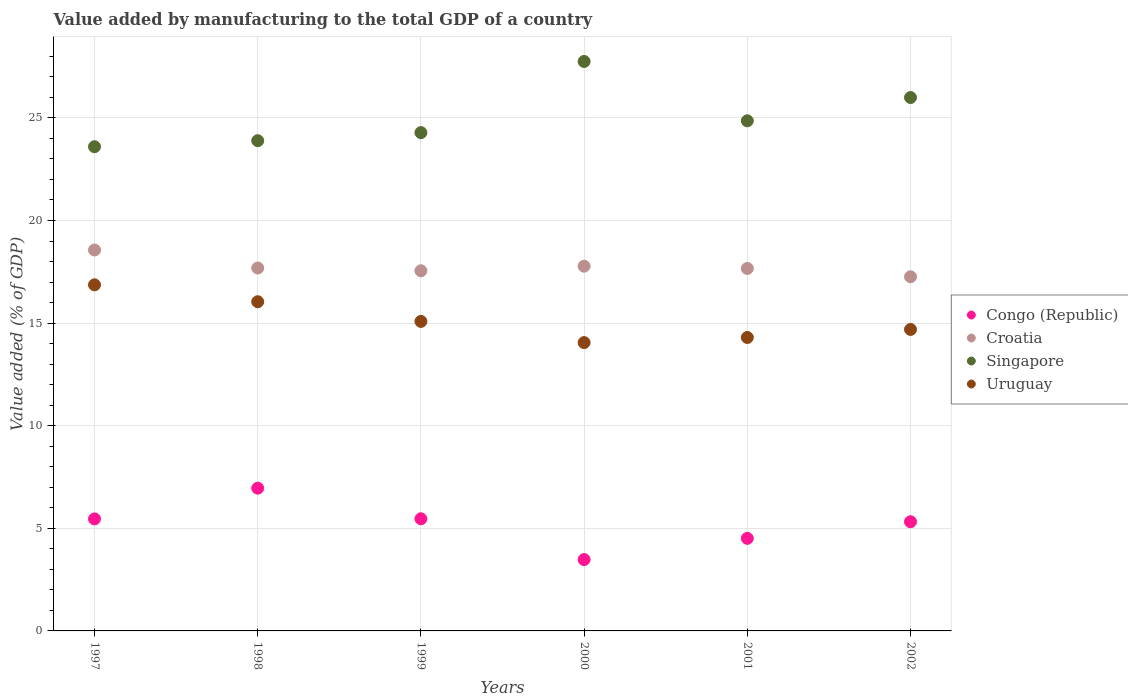How many different coloured dotlines are there?
Provide a succinct answer. 4. What is the value added by manufacturing to the total GDP in Uruguay in 2002?
Your answer should be very brief. 14.69. Across all years, what is the maximum value added by manufacturing to the total GDP in Singapore?
Keep it short and to the point. 27.75. Across all years, what is the minimum value added by manufacturing to the total GDP in Croatia?
Your answer should be very brief. 17.26. What is the total value added by manufacturing to the total GDP in Uruguay in the graph?
Offer a very short reply. 91.03. What is the difference between the value added by manufacturing to the total GDP in Croatia in 1999 and that in 2001?
Give a very brief answer. -0.11. What is the difference between the value added by manufacturing to the total GDP in Congo (Republic) in 2002 and the value added by manufacturing to the total GDP in Singapore in 1999?
Ensure brevity in your answer.  -18.96. What is the average value added by manufacturing to the total GDP in Congo (Republic) per year?
Make the answer very short. 5.2. In the year 1999, what is the difference between the value added by manufacturing to the total GDP in Uruguay and value added by manufacturing to the total GDP in Croatia?
Ensure brevity in your answer.  -2.47. In how many years, is the value added by manufacturing to the total GDP in Congo (Republic) greater than 1 %?
Ensure brevity in your answer.  6. What is the ratio of the value added by manufacturing to the total GDP in Singapore in 1998 to that in 2000?
Give a very brief answer. 0.86. What is the difference between the highest and the second highest value added by manufacturing to the total GDP in Croatia?
Provide a short and direct response. 0.79. What is the difference between the highest and the lowest value added by manufacturing to the total GDP in Congo (Republic)?
Keep it short and to the point. 3.48. In how many years, is the value added by manufacturing to the total GDP in Congo (Republic) greater than the average value added by manufacturing to the total GDP in Congo (Republic) taken over all years?
Offer a very short reply. 4. Is it the case that in every year, the sum of the value added by manufacturing to the total GDP in Congo (Republic) and value added by manufacturing to the total GDP in Croatia  is greater than the sum of value added by manufacturing to the total GDP in Uruguay and value added by manufacturing to the total GDP in Singapore?
Keep it short and to the point. No. Is it the case that in every year, the sum of the value added by manufacturing to the total GDP in Croatia and value added by manufacturing to the total GDP in Uruguay  is greater than the value added by manufacturing to the total GDP in Congo (Republic)?
Offer a terse response. Yes. How many dotlines are there?
Your answer should be compact. 4. Are the values on the major ticks of Y-axis written in scientific E-notation?
Offer a terse response. No. How many legend labels are there?
Provide a short and direct response. 4. What is the title of the graph?
Offer a terse response. Value added by manufacturing to the total GDP of a country. What is the label or title of the X-axis?
Your answer should be compact. Years. What is the label or title of the Y-axis?
Provide a short and direct response. Value added (% of GDP). What is the Value added (% of GDP) in Congo (Republic) in 1997?
Offer a very short reply. 5.46. What is the Value added (% of GDP) of Croatia in 1997?
Your answer should be compact. 18.56. What is the Value added (% of GDP) in Singapore in 1997?
Ensure brevity in your answer.  23.59. What is the Value added (% of GDP) of Uruguay in 1997?
Make the answer very short. 16.86. What is the Value added (% of GDP) of Congo (Republic) in 1998?
Offer a terse response. 6.96. What is the Value added (% of GDP) of Croatia in 1998?
Offer a very short reply. 17.69. What is the Value added (% of GDP) in Singapore in 1998?
Ensure brevity in your answer.  23.89. What is the Value added (% of GDP) of Uruguay in 1998?
Make the answer very short. 16.04. What is the Value added (% of GDP) in Congo (Republic) in 1999?
Your answer should be very brief. 5.46. What is the Value added (% of GDP) in Croatia in 1999?
Ensure brevity in your answer.  17.55. What is the Value added (% of GDP) in Singapore in 1999?
Provide a short and direct response. 24.28. What is the Value added (% of GDP) of Uruguay in 1999?
Make the answer very short. 15.08. What is the Value added (% of GDP) in Congo (Republic) in 2000?
Offer a terse response. 3.48. What is the Value added (% of GDP) in Croatia in 2000?
Offer a very short reply. 17.77. What is the Value added (% of GDP) of Singapore in 2000?
Your response must be concise. 27.75. What is the Value added (% of GDP) in Uruguay in 2000?
Ensure brevity in your answer.  14.05. What is the Value added (% of GDP) in Congo (Republic) in 2001?
Provide a short and direct response. 4.51. What is the Value added (% of GDP) in Croatia in 2001?
Give a very brief answer. 17.66. What is the Value added (% of GDP) in Singapore in 2001?
Ensure brevity in your answer.  24.86. What is the Value added (% of GDP) in Uruguay in 2001?
Offer a terse response. 14.3. What is the Value added (% of GDP) of Congo (Republic) in 2002?
Provide a succinct answer. 5.32. What is the Value added (% of GDP) of Croatia in 2002?
Offer a terse response. 17.26. What is the Value added (% of GDP) in Singapore in 2002?
Keep it short and to the point. 25.99. What is the Value added (% of GDP) of Uruguay in 2002?
Ensure brevity in your answer.  14.69. Across all years, what is the maximum Value added (% of GDP) of Congo (Republic)?
Offer a very short reply. 6.96. Across all years, what is the maximum Value added (% of GDP) of Croatia?
Offer a terse response. 18.56. Across all years, what is the maximum Value added (% of GDP) in Singapore?
Keep it short and to the point. 27.75. Across all years, what is the maximum Value added (% of GDP) in Uruguay?
Ensure brevity in your answer.  16.86. Across all years, what is the minimum Value added (% of GDP) of Congo (Republic)?
Offer a very short reply. 3.48. Across all years, what is the minimum Value added (% of GDP) in Croatia?
Offer a very short reply. 17.26. Across all years, what is the minimum Value added (% of GDP) of Singapore?
Give a very brief answer. 23.59. Across all years, what is the minimum Value added (% of GDP) in Uruguay?
Make the answer very short. 14.05. What is the total Value added (% of GDP) in Congo (Republic) in the graph?
Keep it short and to the point. 31.19. What is the total Value added (% of GDP) in Croatia in the graph?
Provide a short and direct response. 106.49. What is the total Value added (% of GDP) in Singapore in the graph?
Keep it short and to the point. 150.36. What is the total Value added (% of GDP) in Uruguay in the graph?
Make the answer very short. 91.03. What is the difference between the Value added (% of GDP) of Congo (Republic) in 1997 and that in 1998?
Provide a short and direct response. -1.5. What is the difference between the Value added (% of GDP) in Croatia in 1997 and that in 1998?
Make the answer very short. 0.88. What is the difference between the Value added (% of GDP) in Singapore in 1997 and that in 1998?
Provide a succinct answer. -0.29. What is the difference between the Value added (% of GDP) of Uruguay in 1997 and that in 1998?
Your answer should be very brief. 0.82. What is the difference between the Value added (% of GDP) in Congo (Republic) in 1997 and that in 1999?
Your answer should be very brief. -0.01. What is the difference between the Value added (% of GDP) in Croatia in 1997 and that in 1999?
Give a very brief answer. 1.01. What is the difference between the Value added (% of GDP) of Singapore in 1997 and that in 1999?
Provide a short and direct response. -0.69. What is the difference between the Value added (% of GDP) in Uruguay in 1997 and that in 1999?
Your answer should be compact. 1.78. What is the difference between the Value added (% of GDP) in Congo (Republic) in 1997 and that in 2000?
Ensure brevity in your answer.  1.98. What is the difference between the Value added (% of GDP) of Croatia in 1997 and that in 2000?
Offer a very short reply. 0.79. What is the difference between the Value added (% of GDP) of Singapore in 1997 and that in 2000?
Ensure brevity in your answer.  -4.15. What is the difference between the Value added (% of GDP) of Uruguay in 1997 and that in 2000?
Keep it short and to the point. 2.81. What is the difference between the Value added (% of GDP) of Croatia in 1997 and that in 2001?
Offer a terse response. 0.9. What is the difference between the Value added (% of GDP) in Singapore in 1997 and that in 2001?
Your answer should be compact. -1.26. What is the difference between the Value added (% of GDP) of Uruguay in 1997 and that in 2001?
Keep it short and to the point. 2.57. What is the difference between the Value added (% of GDP) of Congo (Republic) in 1997 and that in 2002?
Make the answer very short. 0.14. What is the difference between the Value added (% of GDP) of Croatia in 1997 and that in 2002?
Ensure brevity in your answer.  1.31. What is the difference between the Value added (% of GDP) in Singapore in 1997 and that in 2002?
Offer a very short reply. -2.4. What is the difference between the Value added (% of GDP) of Uruguay in 1997 and that in 2002?
Provide a short and direct response. 2.17. What is the difference between the Value added (% of GDP) of Congo (Republic) in 1998 and that in 1999?
Your answer should be compact. 1.49. What is the difference between the Value added (% of GDP) of Croatia in 1998 and that in 1999?
Your response must be concise. 0.14. What is the difference between the Value added (% of GDP) in Singapore in 1998 and that in 1999?
Give a very brief answer. -0.39. What is the difference between the Value added (% of GDP) of Uruguay in 1998 and that in 1999?
Ensure brevity in your answer.  0.96. What is the difference between the Value added (% of GDP) in Congo (Republic) in 1998 and that in 2000?
Provide a succinct answer. 3.48. What is the difference between the Value added (% of GDP) of Croatia in 1998 and that in 2000?
Give a very brief answer. -0.09. What is the difference between the Value added (% of GDP) in Singapore in 1998 and that in 2000?
Your response must be concise. -3.86. What is the difference between the Value added (% of GDP) of Uruguay in 1998 and that in 2000?
Provide a succinct answer. 1.99. What is the difference between the Value added (% of GDP) in Congo (Republic) in 1998 and that in 2001?
Your answer should be very brief. 2.44. What is the difference between the Value added (% of GDP) in Croatia in 1998 and that in 2001?
Your response must be concise. 0.02. What is the difference between the Value added (% of GDP) of Singapore in 1998 and that in 2001?
Provide a short and direct response. -0.97. What is the difference between the Value added (% of GDP) in Uruguay in 1998 and that in 2001?
Make the answer very short. 1.74. What is the difference between the Value added (% of GDP) of Congo (Republic) in 1998 and that in 2002?
Make the answer very short. 1.64. What is the difference between the Value added (% of GDP) of Croatia in 1998 and that in 2002?
Your answer should be very brief. 0.43. What is the difference between the Value added (% of GDP) in Singapore in 1998 and that in 2002?
Offer a terse response. -2.1. What is the difference between the Value added (% of GDP) of Uruguay in 1998 and that in 2002?
Ensure brevity in your answer.  1.35. What is the difference between the Value added (% of GDP) in Congo (Republic) in 1999 and that in 2000?
Your answer should be compact. 1.99. What is the difference between the Value added (% of GDP) in Croatia in 1999 and that in 2000?
Your response must be concise. -0.22. What is the difference between the Value added (% of GDP) in Singapore in 1999 and that in 2000?
Ensure brevity in your answer.  -3.47. What is the difference between the Value added (% of GDP) of Uruguay in 1999 and that in 2000?
Provide a short and direct response. 1.03. What is the difference between the Value added (% of GDP) in Congo (Republic) in 1999 and that in 2001?
Keep it short and to the point. 0.95. What is the difference between the Value added (% of GDP) in Croatia in 1999 and that in 2001?
Give a very brief answer. -0.11. What is the difference between the Value added (% of GDP) of Singapore in 1999 and that in 2001?
Offer a terse response. -0.58. What is the difference between the Value added (% of GDP) in Uruguay in 1999 and that in 2001?
Keep it short and to the point. 0.78. What is the difference between the Value added (% of GDP) in Congo (Republic) in 1999 and that in 2002?
Your answer should be compact. 0.14. What is the difference between the Value added (% of GDP) of Croatia in 1999 and that in 2002?
Provide a succinct answer. 0.29. What is the difference between the Value added (% of GDP) of Singapore in 1999 and that in 2002?
Offer a terse response. -1.71. What is the difference between the Value added (% of GDP) in Uruguay in 1999 and that in 2002?
Ensure brevity in your answer.  0.39. What is the difference between the Value added (% of GDP) of Congo (Republic) in 2000 and that in 2001?
Provide a succinct answer. -1.03. What is the difference between the Value added (% of GDP) of Croatia in 2000 and that in 2001?
Provide a short and direct response. 0.11. What is the difference between the Value added (% of GDP) of Singapore in 2000 and that in 2001?
Your answer should be compact. 2.89. What is the difference between the Value added (% of GDP) of Uruguay in 2000 and that in 2001?
Your response must be concise. -0.25. What is the difference between the Value added (% of GDP) of Congo (Republic) in 2000 and that in 2002?
Ensure brevity in your answer.  -1.84. What is the difference between the Value added (% of GDP) of Croatia in 2000 and that in 2002?
Make the answer very short. 0.52. What is the difference between the Value added (% of GDP) in Singapore in 2000 and that in 2002?
Keep it short and to the point. 1.76. What is the difference between the Value added (% of GDP) in Uruguay in 2000 and that in 2002?
Offer a very short reply. -0.64. What is the difference between the Value added (% of GDP) in Congo (Republic) in 2001 and that in 2002?
Your answer should be very brief. -0.81. What is the difference between the Value added (% of GDP) of Croatia in 2001 and that in 2002?
Make the answer very short. 0.4. What is the difference between the Value added (% of GDP) of Singapore in 2001 and that in 2002?
Your response must be concise. -1.13. What is the difference between the Value added (% of GDP) of Uruguay in 2001 and that in 2002?
Provide a succinct answer. -0.39. What is the difference between the Value added (% of GDP) of Congo (Republic) in 1997 and the Value added (% of GDP) of Croatia in 1998?
Offer a terse response. -12.23. What is the difference between the Value added (% of GDP) of Congo (Republic) in 1997 and the Value added (% of GDP) of Singapore in 1998?
Your answer should be compact. -18.43. What is the difference between the Value added (% of GDP) in Congo (Republic) in 1997 and the Value added (% of GDP) in Uruguay in 1998?
Your answer should be compact. -10.58. What is the difference between the Value added (% of GDP) in Croatia in 1997 and the Value added (% of GDP) in Singapore in 1998?
Provide a succinct answer. -5.33. What is the difference between the Value added (% of GDP) of Croatia in 1997 and the Value added (% of GDP) of Uruguay in 1998?
Ensure brevity in your answer.  2.52. What is the difference between the Value added (% of GDP) of Singapore in 1997 and the Value added (% of GDP) of Uruguay in 1998?
Your answer should be compact. 7.55. What is the difference between the Value added (% of GDP) in Congo (Republic) in 1997 and the Value added (% of GDP) in Croatia in 1999?
Your answer should be very brief. -12.09. What is the difference between the Value added (% of GDP) of Congo (Republic) in 1997 and the Value added (% of GDP) of Singapore in 1999?
Offer a very short reply. -18.82. What is the difference between the Value added (% of GDP) in Congo (Republic) in 1997 and the Value added (% of GDP) in Uruguay in 1999?
Ensure brevity in your answer.  -9.62. What is the difference between the Value added (% of GDP) in Croatia in 1997 and the Value added (% of GDP) in Singapore in 1999?
Ensure brevity in your answer.  -5.72. What is the difference between the Value added (% of GDP) in Croatia in 1997 and the Value added (% of GDP) in Uruguay in 1999?
Offer a very short reply. 3.48. What is the difference between the Value added (% of GDP) in Singapore in 1997 and the Value added (% of GDP) in Uruguay in 1999?
Your response must be concise. 8.51. What is the difference between the Value added (% of GDP) of Congo (Republic) in 1997 and the Value added (% of GDP) of Croatia in 2000?
Your answer should be compact. -12.32. What is the difference between the Value added (% of GDP) of Congo (Republic) in 1997 and the Value added (% of GDP) of Singapore in 2000?
Provide a succinct answer. -22.29. What is the difference between the Value added (% of GDP) in Congo (Republic) in 1997 and the Value added (% of GDP) in Uruguay in 2000?
Your answer should be very brief. -8.59. What is the difference between the Value added (% of GDP) of Croatia in 1997 and the Value added (% of GDP) of Singapore in 2000?
Give a very brief answer. -9.19. What is the difference between the Value added (% of GDP) in Croatia in 1997 and the Value added (% of GDP) in Uruguay in 2000?
Give a very brief answer. 4.51. What is the difference between the Value added (% of GDP) in Singapore in 1997 and the Value added (% of GDP) in Uruguay in 2000?
Keep it short and to the point. 9.54. What is the difference between the Value added (% of GDP) in Congo (Republic) in 1997 and the Value added (% of GDP) in Croatia in 2001?
Offer a terse response. -12.2. What is the difference between the Value added (% of GDP) of Congo (Republic) in 1997 and the Value added (% of GDP) of Singapore in 2001?
Offer a very short reply. -19.4. What is the difference between the Value added (% of GDP) of Congo (Republic) in 1997 and the Value added (% of GDP) of Uruguay in 2001?
Offer a very short reply. -8.84. What is the difference between the Value added (% of GDP) of Croatia in 1997 and the Value added (% of GDP) of Singapore in 2001?
Your response must be concise. -6.29. What is the difference between the Value added (% of GDP) of Croatia in 1997 and the Value added (% of GDP) of Uruguay in 2001?
Your answer should be compact. 4.26. What is the difference between the Value added (% of GDP) of Singapore in 1997 and the Value added (% of GDP) of Uruguay in 2001?
Your response must be concise. 9.3. What is the difference between the Value added (% of GDP) of Congo (Republic) in 1997 and the Value added (% of GDP) of Croatia in 2002?
Your answer should be very brief. -11.8. What is the difference between the Value added (% of GDP) in Congo (Republic) in 1997 and the Value added (% of GDP) in Singapore in 2002?
Offer a very short reply. -20.53. What is the difference between the Value added (% of GDP) of Congo (Republic) in 1997 and the Value added (% of GDP) of Uruguay in 2002?
Give a very brief answer. -9.23. What is the difference between the Value added (% of GDP) in Croatia in 1997 and the Value added (% of GDP) in Singapore in 2002?
Provide a short and direct response. -7.43. What is the difference between the Value added (% of GDP) of Croatia in 1997 and the Value added (% of GDP) of Uruguay in 2002?
Provide a succinct answer. 3.87. What is the difference between the Value added (% of GDP) of Singapore in 1997 and the Value added (% of GDP) of Uruguay in 2002?
Offer a very short reply. 8.9. What is the difference between the Value added (% of GDP) of Congo (Republic) in 1998 and the Value added (% of GDP) of Croatia in 1999?
Ensure brevity in your answer.  -10.59. What is the difference between the Value added (% of GDP) in Congo (Republic) in 1998 and the Value added (% of GDP) in Singapore in 1999?
Give a very brief answer. -17.33. What is the difference between the Value added (% of GDP) in Congo (Republic) in 1998 and the Value added (% of GDP) in Uruguay in 1999?
Give a very brief answer. -8.13. What is the difference between the Value added (% of GDP) of Croatia in 1998 and the Value added (% of GDP) of Singapore in 1999?
Give a very brief answer. -6.6. What is the difference between the Value added (% of GDP) of Croatia in 1998 and the Value added (% of GDP) of Uruguay in 1999?
Make the answer very short. 2.6. What is the difference between the Value added (% of GDP) in Singapore in 1998 and the Value added (% of GDP) in Uruguay in 1999?
Provide a succinct answer. 8.81. What is the difference between the Value added (% of GDP) of Congo (Republic) in 1998 and the Value added (% of GDP) of Croatia in 2000?
Your answer should be very brief. -10.82. What is the difference between the Value added (% of GDP) in Congo (Republic) in 1998 and the Value added (% of GDP) in Singapore in 2000?
Provide a succinct answer. -20.79. What is the difference between the Value added (% of GDP) of Congo (Republic) in 1998 and the Value added (% of GDP) of Uruguay in 2000?
Offer a terse response. -7.09. What is the difference between the Value added (% of GDP) of Croatia in 1998 and the Value added (% of GDP) of Singapore in 2000?
Make the answer very short. -10.06. What is the difference between the Value added (% of GDP) in Croatia in 1998 and the Value added (% of GDP) in Uruguay in 2000?
Make the answer very short. 3.63. What is the difference between the Value added (% of GDP) of Singapore in 1998 and the Value added (% of GDP) of Uruguay in 2000?
Give a very brief answer. 9.84. What is the difference between the Value added (% of GDP) in Congo (Republic) in 1998 and the Value added (% of GDP) in Croatia in 2001?
Provide a short and direct response. -10.71. What is the difference between the Value added (% of GDP) in Congo (Republic) in 1998 and the Value added (% of GDP) in Singapore in 2001?
Your answer should be compact. -17.9. What is the difference between the Value added (% of GDP) of Congo (Republic) in 1998 and the Value added (% of GDP) of Uruguay in 2001?
Your response must be concise. -7.34. What is the difference between the Value added (% of GDP) in Croatia in 1998 and the Value added (% of GDP) in Singapore in 2001?
Offer a terse response. -7.17. What is the difference between the Value added (% of GDP) of Croatia in 1998 and the Value added (% of GDP) of Uruguay in 2001?
Your answer should be compact. 3.39. What is the difference between the Value added (% of GDP) in Singapore in 1998 and the Value added (% of GDP) in Uruguay in 2001?
Your answer should be very brief. 9.59. What is the difference between the Value added (% of GDP) in Congo (Republic) in 1998 and the Value added (% of GDP) in Croatia in 2002?
Make the answer very short. -10.3. What is the difference between the Value added (% of GDP) of Congo (Republic) in 1998 and the Value added (% of GDP) of Singapore in 2002?
Make the answer very short. -19.04. What is the difference between the Value added (% of GDP) in Congo (Republic) in 1998 and the Value added (% of GDP) in Uruguay in 2002?
Your response must be concise. -7.74. What is the difference between the Value added (% of GDP) in Croatia in 1998 and the Value added (% of GDP) in Singapore in 2002?
Your answer should be compact. -8.31. What is the difference between the Value added (% of GDP) of Croatia in 1998 and the Value added (% of GDP) of Uruguay in 2002?
Make the answer very short. 2.99. What is the difference between the Value added (% of GDP) in Singapore in 1998 and the Value added (% of GDP) in Uruguay in 2002?
Make the answer very short. 9.2. What is the difference between the Value added (% of GDP) of Congo (Republic) in 1999 and the Value added (% of GDP) of Croatia in 2000?
Provide a succinct answer. -12.31. What is the difference between the Value added (% of GDP) in Congo (Republic) in 1999 and the Value added (% of GDP) in Singapore in 2000?
Make the answer very short. -22.28. What is the difference between the Value added (% of GDP) in Congo (Republic) in 1999 and the Value added (% of GDP) in Uruguay in 2000?
Offer a terse response. -8.59. What is the difference between the Value added (% of GDP) of Croatia in 1999 and the Value added (% of GDP) of Singapore in 2000?
Make the answer very short. -10.2. What is the difference between the Value added (% of GDP) of Croatia in 1999 and the Value added (% of GDP) of Uruguay in 2000?
Your answer should be very brief. 3.5. What is the difference between the Value added (% of GDP) in Singapore in 1999 and the Value added (% of GDP) in Uruguay in 2000?
Offer a very short reply. 10.23. What is the difference between the Value added (% of GDP) in Congo (Republic) in 1999 and the Value added (% of GDP) in Croatia in 2001?
Provide a succinct answer. -12.2. What is the difference between the Value added (% of GDP) of Congo (Republic) in 1999 and the Value added (% of GDP) of Singapore in 2001?
Keep it short and to the point. -19.39. What is the difference between the Value added (% of GDP) in Congo (Republic) in 1999 and the Value added (% of GDP) in Uruguay in 2001?
Your response must be concise. -8.83. What is the difference between the Value added (% of GDP) in Croatia in 1999 and the Value added (% of GDP) in Singapore in 2001?
Provide a short and direct response. -7.31. What is the difference between the Value added (% of GDP) of Croatia in 1999 and the Value added (% of GDP) of Uruguay in 2001?
Offer a very short reply. 3.25. What is the difference between the Value added (% of GDP) in Singapore in 1999 and the Value added (% of GDP) in Uruguay in 2001?
Ensure brevity in your answer.  9.98. What is the difference between the Value added (% of GDP) of Congo (Republic) in 1999 and the Value added (% of GDP) of Croatia in 2002?
Offer a terse response. -11.79. What is the difference between the Value added (% of GDP) of Congo (Republic) in 1999 and the Value added (% of GDP) of Singapore in 2002?
Ensure brevity in your answer.  -20.53. What is the difference between the Value added (% of GDP) in Congo (Republic) in 1999 and the Value added (% of GDP) in Uruguay in 2002?
Give a very brief answer. -9.23. What is the difference between the Value added (% of GDP) of Croatia in 1999 and the Value added (% of GDP) of Singapore in 2002?
Ensure brevity in your answer.  -8.44. What is the difference between the Value added (% of GDP) in Croatia in 1999 and the Value added (% of GDP) in Uruguay in 2002?
Keep it short and to the point. 2.86. What is the difference between the Value added (% of GDP) in Singapore in 1999 and the Value added (% of GDP) in Uruguay in 2002?
Offer a terse response. 9.59. What is the difference between the Value added (% of GDP) in Congo (Republic) in 2000 and the Value added (% of GDP) in Croatia in 2001?
Provide a short and direct response. -14.18. What is the difference between the Value added (% of GDP) in Congo (Republic) in 2000 and the Value added (% of GDP) in Singapore in 2001?
Provide a succinct answer. -21.38. What is the difference between the Value added (% of GDP) of Congo (Republic) in 2000 and the Value added (% of GDP) of Uruguay in 2001?
Offer a very short reply. -10.82. What is the difference between the Value added (% of GDP) of Croatia in 2000 and the Value added (% of GDP) of Singapore in 2001?
Keep it short and to the point. -7.08. What is the difference between the Value added (% of GDP) of Croatia in 2000 and the Value added (% of GDP) of Uruguay in 2001?
Your response must be concise. 3.47. What is the difference between the Value added (% of GDP) of Singapore in 2000 and the Value added (% of GDP) of Uruguay in 2001?
Make the answer very short. 13.45. What is the difference between the Value added (% of GDP) of Congo (Republic) in 2000 and the Value added (% of GDP) of Croatia in 2002?
Provide a succinct answer. -13.78. What is the difference between the Value added (% of GDP) in Congo (Republic) in 2000 and the Value added (% of GDP) in Singapore in 2002?
Give a very brief answer. -22.52. What is the difference between the Value added (% of GDP) of Congo (Republic) in 2000 and the Value added (% of GDP) of Uruguay in 2002?
Provide a succinct answer. -11.22. What is the difference between the Value added (% of GDP) of Croatia in 2000 and the Value added (% of GDP) of Singapore in 2002?
Your response must be concise. -8.22. What is the difference between the Value added (% of GDP) in Croatia in 2000 and the Value added (% of GDP) in Uruguay in 2002?
Offer a very short reply. 3.08. What is the difference between the Value added (% of GDP) in Singapore in 2000 and the Value added (% of GDP) in Uruguay in 2002?
Offer a very short reply. 13.06. What is the difference between the Value added (% of GDP) in Congo (Republic) in 2001 and the Value added (% of GDP) in Croatia in 2002?
Offer a very short reply. -12.75. What is the difference between the Value added (% of GDP) of Congo (Republic) in 2001 and the Value added (% of GDP) of Singapore in 2002?
Your response must be concise. -21.48. What is the difference between the Value added (% of GDP) in Congo (Republic) in 2001 and the Value added (% of GDP) in Uruguay in 2002?
Your response must be concise. -10.18. What is the difference between the Value added (% of GDP) of Croatia in 2001 and the Value added (% of GDP) of Singapore in 2002?
Your answer should be compact. -8.33. What is the difference between the Value added (% of GDP) in Croatia in 2001 and the Value added (% of GDP) in Uruguay in 2002?
Your response must be concise. 2.97. What is the difference between the Value added (% of GDP) of Singapore in 2001 and the Value added (% of GDP) of Uruguay in 2002?
Offer a very short reply. 10.17. What is the average Value added (% of GDP) of Congo (Republic) per year?
Give a very brief answer. 5.2. What is the average Value added (% of GDP) in Croatia per year?
Your answer should be compact. 17.75. What is the average Value added (% of GDP) in Singapore per year?
Give a very brief answer. 25.06. What is the average Value added (% of GDP) of Uruguay per year?
Offer a terse response. 15.17. In the year 1997, what is the difference between the Value added (% of GDP) of Congo (Republic) and Value added (% of GDP) of Croatia?
Provide a succinct answer. -13.1. In the year 1997, what is the difference between the Value added (% of GDP) of Congo (Republic) and Value added (% of GDP) of Singapore?
Keep it short and to the point. -18.14. In the year 1997, what is the difference between the Value added (% of GDP) of Congo (Republic) and Value added (% of GDP) of Uruguay?
Keep it short and to the point. -11.41. In the year 1997, what is the difference between the Value added (% of GDP) in Croatia and Value added (% of GDP) in Singapore?
Your answer should be compact. -5.03. In the year 1997, what is the difference between the Value added (% of GDP) of Croatia and Value added (% of GDP) of Uruguay?
Your answer should be compact. 1.7. In the year 1997, what is the difference between the Value added (% of GDP) of Singapore and Value added (% of GDP) of Uruguay?
Your response must be concise. 6.73. In the year 1998, what is the difference between the Value added (% of GDP) of Congo (Republic) and Value added (% of GDP) of Croatia?
Make the answer very short. -10.73. In the year 1998, what is the difference between the Value added (% of GDP) in Congo (Republic) and Value added (% of GDP) in Singapore?
Your response must be concise. -16.93. In the year 1998, what is the difference between the Value added (% of GDP) in Congo (Republic) and Value added (% of GDP) in Uruguay?
Give a very brief answer. -9.09. In the year 1998, what is the difference between the Value added (% of GDP) of Croatia and Value added (% of GDP) of Singapore?
Your response must be concise. -6.2. In the year 1998, what is the difference between the Value added (% of GDP) in Croatia and Value added (% of GDP) in Uruguay?
Offer a terse response. 1.64. In the year 1998, what is the difference between the Value added (% of GDP) in Singapore and Value added (% of GDP) in Uruguay?
Ensure brevity in your answer.  7.85. In the year 1999, what is the difference between the Value added (% of GDP) of Congo (Republic) and Value added (% of GDP) of Croatia?
Offer a very short reply. -12.09. In the year 1999, what is the difference between the Value added (% of GDP) of Congo (Republic) and Value added (% of GDP) of Singapore?
Your response must be concise. -18.82. In the year 1999, what is the difference between the Value added (% of GDP) of Congo (Republic) and Value added (% of GDP) of Uruguay?
Your answer should be compact. -9.62. In the year 1999, what is the difference between the Value added (% of GDP) in Croatia and Value added (% of GDP) in Singapore?
Keep it short and to the point. -6.73. In the year 1999, what is the difference between the Value added (% of GDP) of Croatia and Value added (% of GDP) of Uruguay?
Your answer should be compact. 2.47. In the year 1999, what is the difference between the Value added (% of GDP) of Singapore and Value added (% of GDP) of Uruguay?
Keep it short and to the point. 9.2. In the year 2000, what is the difference between the Value added (% of GDP) in Congo (Republic) and Value added (% of GDP) in Croatia?
Keep it short and to the point. -14.3. In the year 2000, what is the difference between the Value added (% of GDP) of Congo (Republic) and Value added (% of GDP) of Singapore?
Ensure brevity in your answer.  -24.27. In the year 2000, what is the difference between the Value added (% of GDP) of Congo (Republic) and Value added (% of GDP) of Uruguay?
Make the answer very short. -10.57. In the year 2000, what is the difference between the Value added (% of GDP) in Croatia and Value added (% of GDP) in Singapore?
Give a very brief answer. -9.97. In the year 2000, what is the difference between the Value added (% of GDP) in Croatia and Value added (% of GDP) in Uruguay?
Offer a terse response. 3.72. In the year 2000, what is the difference between the Value added (% of GDP) of Singapore and Value added (% of GDP) of Uruguay?
Ensure brevity in your answer.  13.7. In the year 2001, what is the difference between the Value added (% of GDP) in Congo (Republic) and Value added (% of GDP) in Croatia?
Your answer should be compact. -13.15. In the year 2001, what is the difference between the Value added (% of GDP) in Congo (Republic) and Value added (% of GDP) in Singapore?
Your response must be concise. -20.35. In the year 2001, what is the difference between the Value added (% of GDP) in Congo (Republic) and Value added (% of GDP) in Uruguay?
Provide a succinct answer. -9.79. In the year 2001, what is the difference between the Value added (% of GDP) in Croatia and Value added (% of GDP) in Singapore?
Your response must be concise. -7.2. In the year 2001, what is the difference between the Value added (% of GDP) in Croatia and Value added (% of GDP) in Uruguay?
Make the answer very short. 3.36. In the year 2001, what is the difference between the Value added (% of GDP) of Singapore and Value added (% of GDP) of Uruguay?
Offer a very short reply. 10.56. In the year 2002, what is the difference between the Value added (% of GDP) of Congo (Republic) and Value added (% of GDP) of Croatia?
Your answer should be very brief. -11.94. In the year 2002, what is the difference between the Value added (% of GDP) in Congo (Republic) and Value added (% of GDP) in Singapore?
Ensure brevity in your answer.  -20.67. In the year 2002, what is the difference between the Value added (% of GDP) in Congo (Republic) and Value added (% of GDP) in Uruguay?
Give a very brief answer. -9.37. In the year 2002, what is the difference between the Value added (% of GDP) of Croatia and Value added (% of GDP) of Singapore?
Ensure brevity in your answer.  -8.73. In the year 2002, what is the difference between the Value added (% of GDP) in Croatia and Value added (% of GDP) in Uruguay?
Provide a short and direct response. 2.56. In the year 2002, what is the difference between the Value added (% of GDP) in Singapore and Value added (% of GDP) in Uruguay?
Provide a short and direct response. 11.3. What is the ratio of the Value added (% of GDP) in Congo (Republic) in 1997 to that in 1998?
Offer a terse response. 0.78. What is the ratio of the Value added (% of GDP) of Croatia in 1997 to that in 1998?
Give a very brief answer. 1.05. What is the ratio of the Value added (% of GDP) in Singapore in 1997 to that in 1998?
Your answer should be compact. 0.99. What is the ratio of the Value added (% of GDP) in Uruguay in 1997 to that in 1998?
Make the answer very short. 1.05. What is the ratio of the Value added (% of GDP) of Congo (Republic) in 1997 to that in 1999?
Keep it short and to the point. 1. What is the ratio of the Value added (% of GDP) of Croatia in 1997 to that in 1999?
Offer a terse response. 1.06. What is the ratio of the Value added (% of GDP) in Singapore in 1997 to that in 1999?
Ensure brevity in your answer.  0.97. What is the ratio of the Value added (% of GDP) of Uruguay in 1997 to that in 1999?
Keep it short and to the point. 1.12. What is the ratio of the Value added (% of GDP) of Congo (Republic) in 1997 to that in 2000?
Keep it short and to the point. 1.57. What is the ratio of the Value added (% of GDP) of Croatia in 1997 to that in 2000?
Your answer should be compact. 1.04. What is the ratio of the Value added (% of GDP) of Singapore in 1997 to that in 2000?
Provide a short and direct response. 0.85. What is the ratio of the Value added (% of GDP) in Uruguay in 1997 to that in 2000?
Provide a short and direct response. 1.2. What is the ratio of the Value added (% of GDP) of Congo (Republic) in 1997 to that in 2001?
Provide a short and direct response. 1.21. What is the ratio of the Value added (% of GDP) of Croatia in 1997 to that in 2001?
Your response must be concise. 1.05. What is the ratio of the Value added (% of GDP) of Singapore in 1997 to that in 2001?
Give a very brief answer. 0.95. What is the ratio of the Value added (% of GDP) in Uruguay in 1997 to that in 2001?
Give a very brief answer. 1.18. What is the ratio of the Value added (% of GDP) in Congo (Republic) in 1997 to that in 2002?
Make the answer very short. 1.03. What is the ratio of the Value added (% of GDP) in Croatia in 1997 to that in 2002?
Your answer should be very brief. 1.08. What is the ratio of the Value added (% of GDP) of Singapore in 1997 to that in 2002?
Ensure brevity in your answer.  0.91. What is the ratio of the Value added (% of GDP) in Uruguay in 1997 to that in 2002?
Ensure brevity in your answer.  1.15. What is the ratio of the Value added (% of GDP) in Congo (Republic) in 1998 to that in 1999?
Your response must be concise. 1.27. What is the ratio of the Value added (% of GDP) of Croatia in 1998 to that in 1999?
Make the answer very short. 1.01. What is the ratio of the Value added (% of GDP) of Singapore in 1998 to that in 1999?
Provide a succinct answer. 0.98. What is the ratio of the Value added (% of GDP) of Uruguay in 1998 to that in 1999?
Your answer should be compact. 1.06. What is the ratio of the Value added (% of GDP) of Congo (Republic) in 1998 to that in 2000?
Provide a short and direct response. 2. What is the ratio of the Value added (% of GDP) of Croatia in 1998 to that in 2000?
Your response must be concise. 0.99. What is the ratio of the Value added (% of GDP) of Singapore in 1998 to that in 2000?
Your answer should be compact. 0.86. What is the ratio of the Value added (% of GDP) in Uruguay in 1998 to that in 2000?
Offer a very short reply. 1.14. What is the ratio of the Value added (% of GDP) of Congo (Republic) in 1998 to that in 2001?
Your response must be concise. 1.54. What is the ratio of the Value added (% of GDP) in Croatia in 1998 to that in 2001?
Offer a very short reply. 1. What is the ratio of the Value added (% of GDP) in Uruguay in 1998 to that in 2001?
Provide a short and direct response. 1.12. What is the ratio of the Value added (% of GDP) of Congo (Republic) in 1998 to that in 2002?
Make the answer very short. 1.31. What is the ratio of the Value added (% of GDP) of Croatia in 1998 to that in 2002?
Your answer should be compact. 1.02. What is the ratio of the Value added (% of GDP) of Singapore in 1998 to that in 2002?
Your answer should be very brief. 0.92. What is the ratio of the Value added (% of GDP) in Uruguay in 1998 to that in 2002?
Your answer should be compact. 1.09. What is the ratio of the Value added (% of GDP) of Congo (Republic) in 1999 to that in 2000?
Ensure brevity in your answer.  1.57. What is the ratio of the Value added (% of GDP) of Croatia in 1999 to that in 2000?
Give a very brief answer. 0.99. What is the ratio of the Value added (% of GDP) of Singapore in 1999 to that in 2000?
Provide a short and direct response. 0.88. What is the ratio of the Value added (% of GDP) of Uruguay in 1999 to that in 2000?
Provide a short and direct response. 1.07. What is the ratio of the Value added (% of GDP) of Congo (Republic) in 1999 to that in 2001?
Offer a terse response. 1.21. What is the ratio of the Value added (% of GDP) in Singapore in 1999 to that in 2001?
Give a very brief answer. 0.98. What is the ratio of the Value added (% of GDP) in Uruguay in 1999 to that in 2001?
Your answer should be compact. 1.05. What is the ratio of the Value added (% of GDP) of Congo (Republic) in 1999 to that in 2002?
Provide a short and direct response. 1.03. What is the ratio of the Value added (% of GDP) in Croatia in 1999 to that in 2002?
Your answer should be compact. 1.02. What is the ratio of the Value added (% of GDP) in Singapore in 1999 to that in 2002?
Ensure brevity in your answer.  0.93. What is the ratio of the Value added (% of GDP) of Uruguay in 1999 to that in 2002?
Ensure brevity in your answer.  1.03. What is the ratio of the Value added (% of GDP) of Congo (Republic) in 2000 to that in 2001?
Offer a terse response. 0.77. What is the ratio of the Value added (% of GDP) of Croatia in 2000 to that in 2001?
Give a very brief answer. 1.01. What is the ratio of the Value added (% of GDP) in Singapore in 2000 to that in 2001?
Your response must be concise. 1.12. What is the ratio of the Value added (% of GDP) of Uruguay in 2000 to that in 2001?
Ensure brevity in your answer.  0.98. What is the ratio of the Value added (% of GDP) of Congo (Republic) in 2000 to that in 2002?
Ensure brevity in your answer.  0.65. What is the ratio of the Value added (% of GDP) of Singapore in 2000 to that in 2002?
Provide a short and direct response. 1.07. What is the ratio of the Value added (% of GDP) of Uruguay in 2000 to that in 2002?
Make the answer very short. 0.96. What is the ratio of the Value added (% of GDP) in Congo (Republic) in 2001 to that in 2002?
Provide a succinct answer. 0.85. What is the ratio of the Value added (% of GDP) of Croatia in 2001 to that in 2002?
Your answer should be compact. 1.02. What is the ratio of the Value added (% of GDP) of Singapore in 2001 to that in 2002?
Keep it short and to the point. 0.96. What is the ratio of the Value added (% of GDP) in Uruguay in 2001 to that in 2002?
Offer a very short reply. 0.97. What is the difference between the highest and the second highest Value added (% of GDP) in Congo (Republic)?
Provide a succinct answer. 1.49. What is the difference between the highest and the second highest Value added (% of GDP) in Croatia?
Ensure brevity in your answer.  0.79. What is the difference between the highest and the second highest Value added (% of GDP) of Singapore?
Provide a short and direct response. 1.76. What is the difference between the highest and the second highest Value added (% of GDP) in Uruguay?
Your answer should be very brief. 0.82. What is the difference between the highest and the lowest Value added (% of GDP) in Congo (Republic)?
Ensure brevity in your answer.  3.48. What is the difference between the highest and the lowest Value added (% of GDP) in Croatia?
Your answer should be very brief. 1.31. What is the difference between the highest and the lowest Value added (% of GDP) in Singapore?
Your answer should be very brief. 4.15. What is the difference between the highest and the lowest Value added (% of GDP) in Uruguay?
Give a very brief answer. 2.81. 